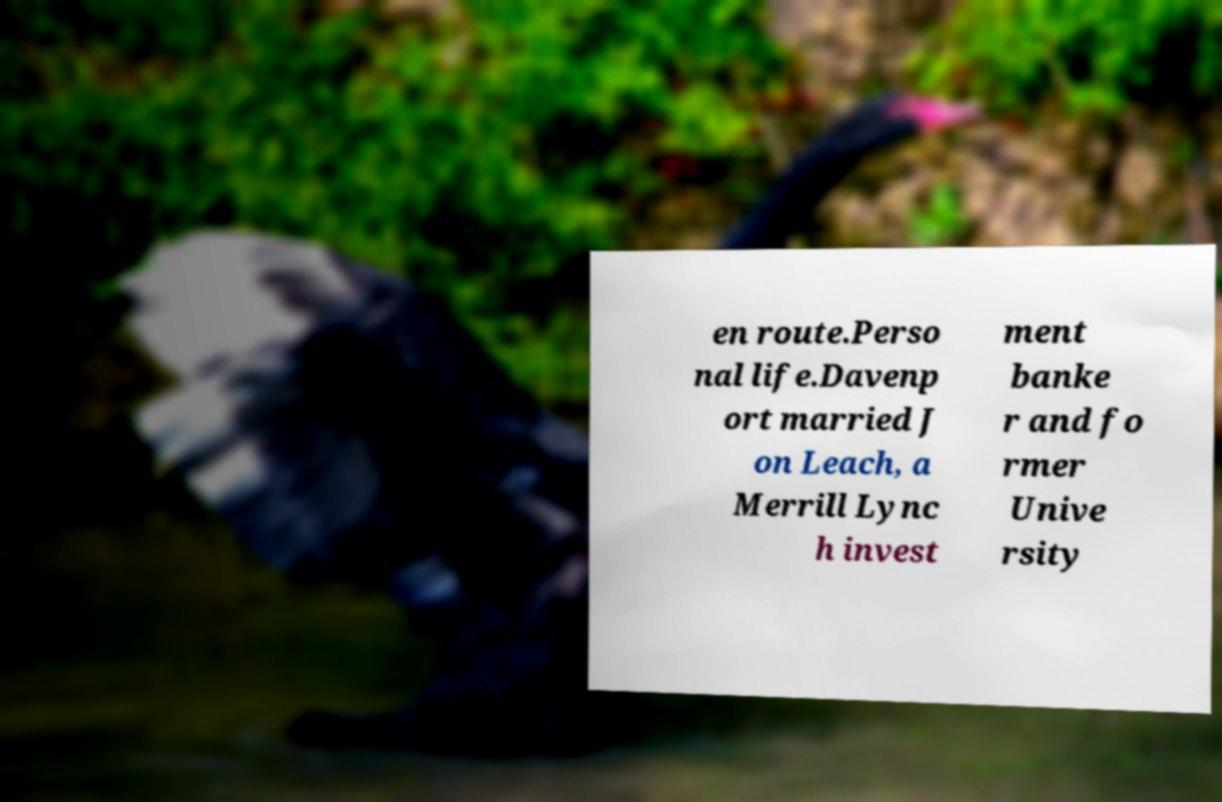Could you extract and type out the text from this image? en route.Perso nal life.Davenp ort married J on Leach, a Merrill Lync h invest ment banke r and fo rmer Unive rsity 